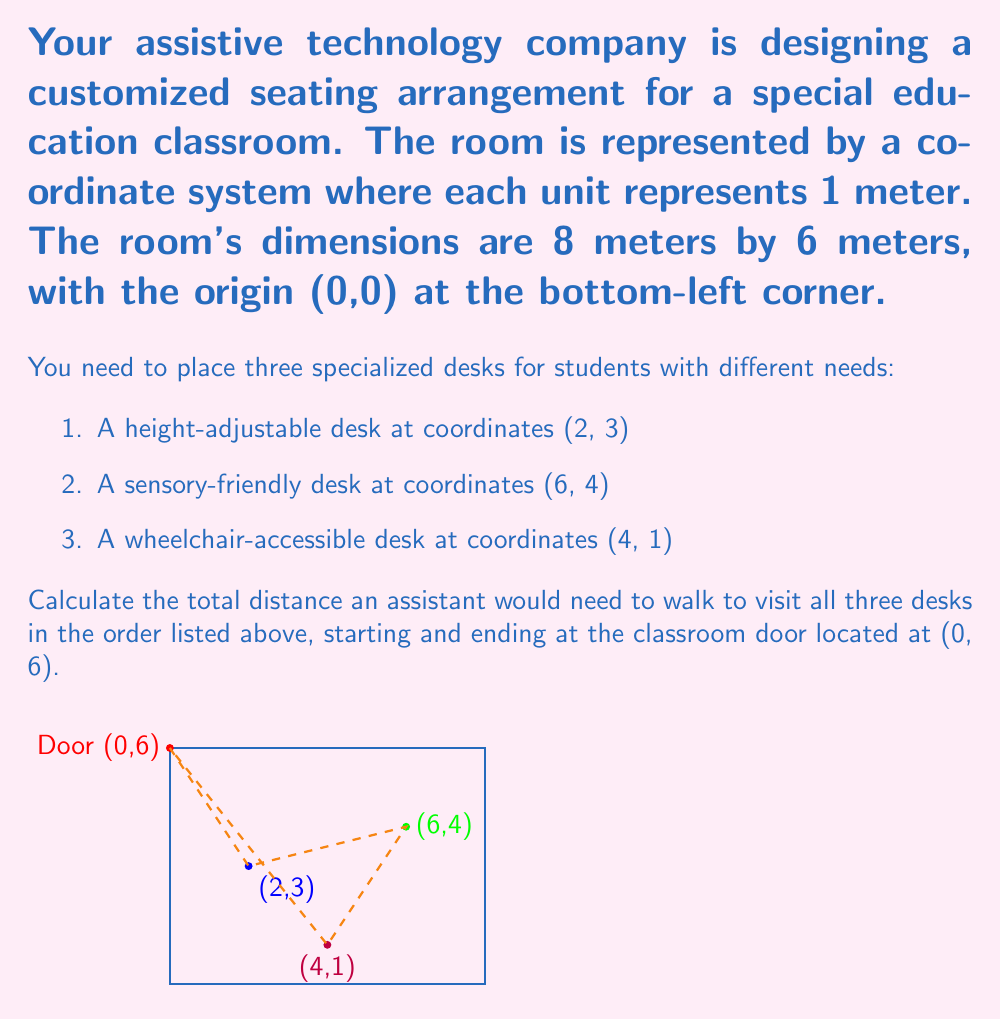Give your solution to this math problem. Let's approach this problem step-by-step using the distance formula between two points in a coordinate system:

$d = \sqrt{(x_2-x_1)^2 + (y_2-y_1)^2}$

1. Distance from door to height-adjustable desk:
   $d_1 = \sqrt{(2-0)^2 + (3-6)^2} = \sqrt{4 + 9} = \sqrt{13}$ meters

2. Distance from height-adjustable desk to sensory-friendly desk:
   $d_2 = \sqrt{(6-2)^2 + (4-3)^2} = \sqrt{16 + 1} = \sqrt{17}$ meters

3. Distance from sensory-friendly desk to wheelchair-accessible desk:
   $d_3 = \sqrt{(4-6)^2 + (1-4)^2} = \sqrt{4 + 9} = \sqrt{13}$ meters

4. Distance from wheelchair-accessible desk back to the door:
   $d_4 = \sqrt{(0-4)^2 + (6-1)^2} = \sqrt{16 + 25} = \sqrt{41}$ meters

5. Total distance:
   $d_{total} = d_1 + d_2 + d_3 + d_4$
   $d_{total} = \sqrt{13} + \sqrt{17} + \sqrt{13} + \sqrt{41}$ meters

To simplify, we can leave the answer in this form as it's exact. If a decimal approximation is needed, we can calculate:

$d_{total} \approx 3.61 + 4.12 + 3.61 + 6.40 \approx 17.74$ meters
Answer: $\sqrt{13} + \sqrt{17} + \sqrt{13} + \sqrt{41}$ meters 